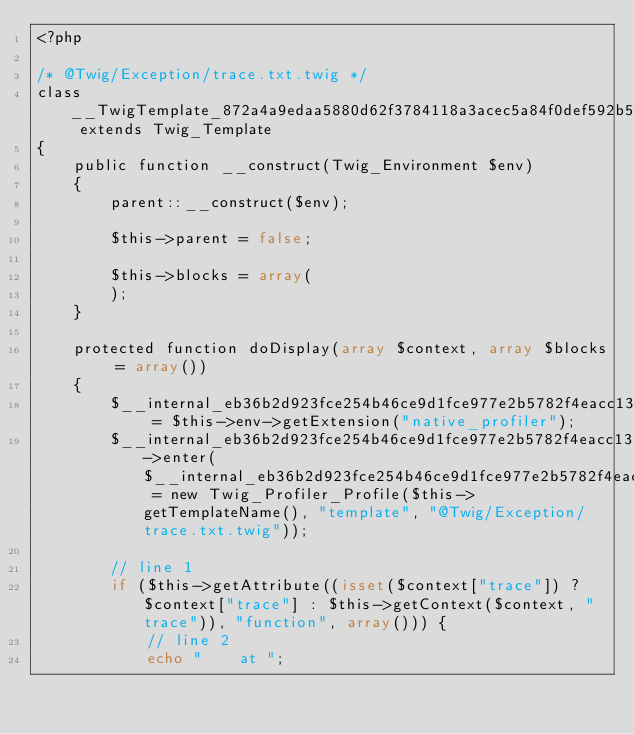<code> <loc_0><loc_0><loc_500><loc_500><_PHP_><?php

/* @Twig/Exception/trace.txt.twig */
class __TwigTemplate_872a4a9edaa5880d62f3784118a3acec5a84f0def592b5c5b8e874ca275c1a71 extends Twig_Template
{
    public function __construct(Twig_Environment $env)
    {
        parent::__construct($env);

        $this->parent = false;

        $this->blocks = array(
        );
    }

    protected function doDisplay(array $context, array $blocks = array())
    {
        $__internal_eb36b2d923fce254b46ce9d1fce977e2b5782f4eacc135d4d90587144ffd37ba = $this->env->getExtension("native_profiler");
        $__internal_eb36b2d923fce254b46ce9d1fce977e2b5782f4eacc135d4d90587144ffd37ba->enter($__internal_eb36b2d923fce254b46ce9d1fce977e2b5782f4eacc135d4d90587144ffd37ba_prof = new Twig_Profiler_Profile($this->getTemplateName(), "template", "@Twig/Exception/trace.txt.twig"));

        // line 1
        if ($this->getAttribute((isset($context["trace"]) ? $context["trace"] : $this->getContext($context, "trace")), "function", array())) {
            // line 2
            echo "    at ";</code> 